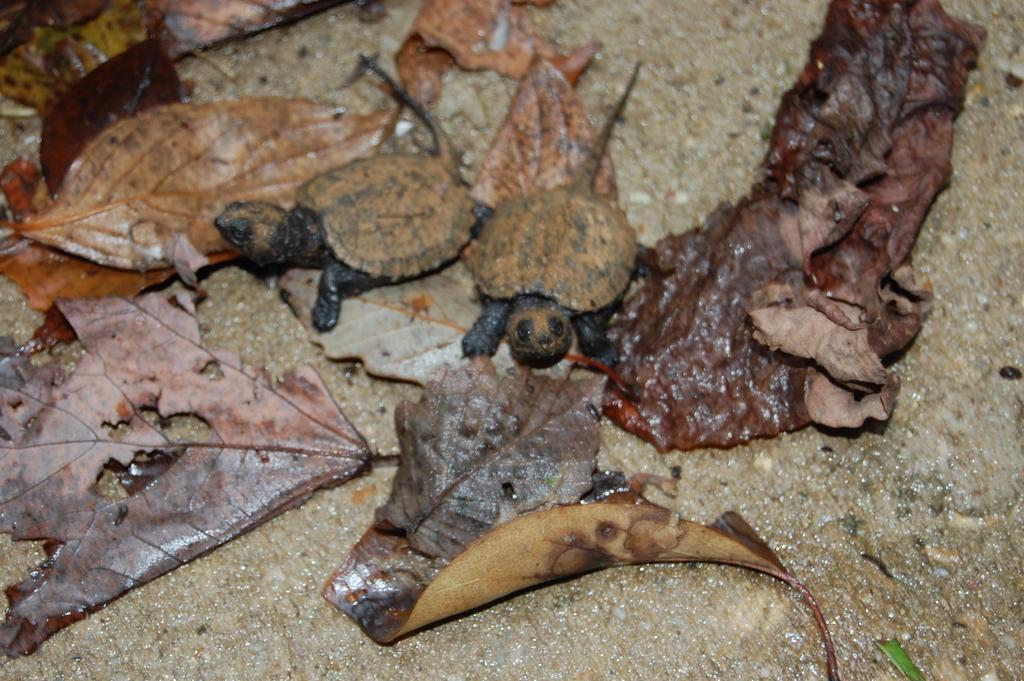How would you summarize this image in a sentence or two? In the foreground of this image, there are two turtles and few leafs are on the ground. 